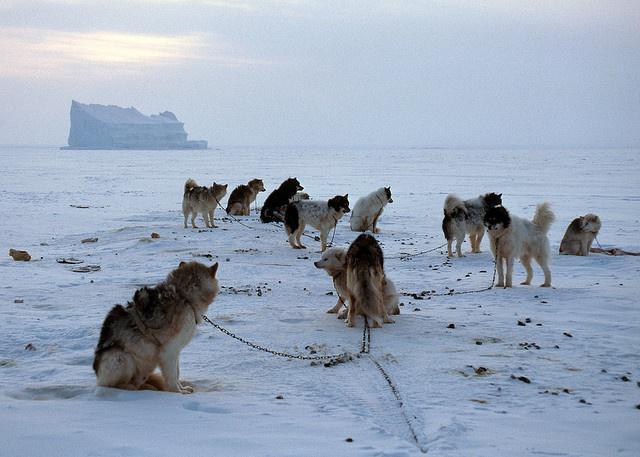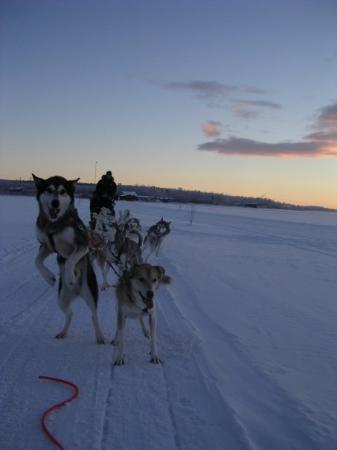The first image is the image on the left, the second image is the image on the right. Assess this claim about the two images: "In one of the images the photographer's sled is being pulled by dogs.". Correct or not? Answer yes or no. No. The first image is the image on the left, the second image is the image on the right. Evaluate the accuracy of this statement regarding the images: "In the left image, the sled dog team is taking a break.". Is it true? Answer yes or no. Yes. 